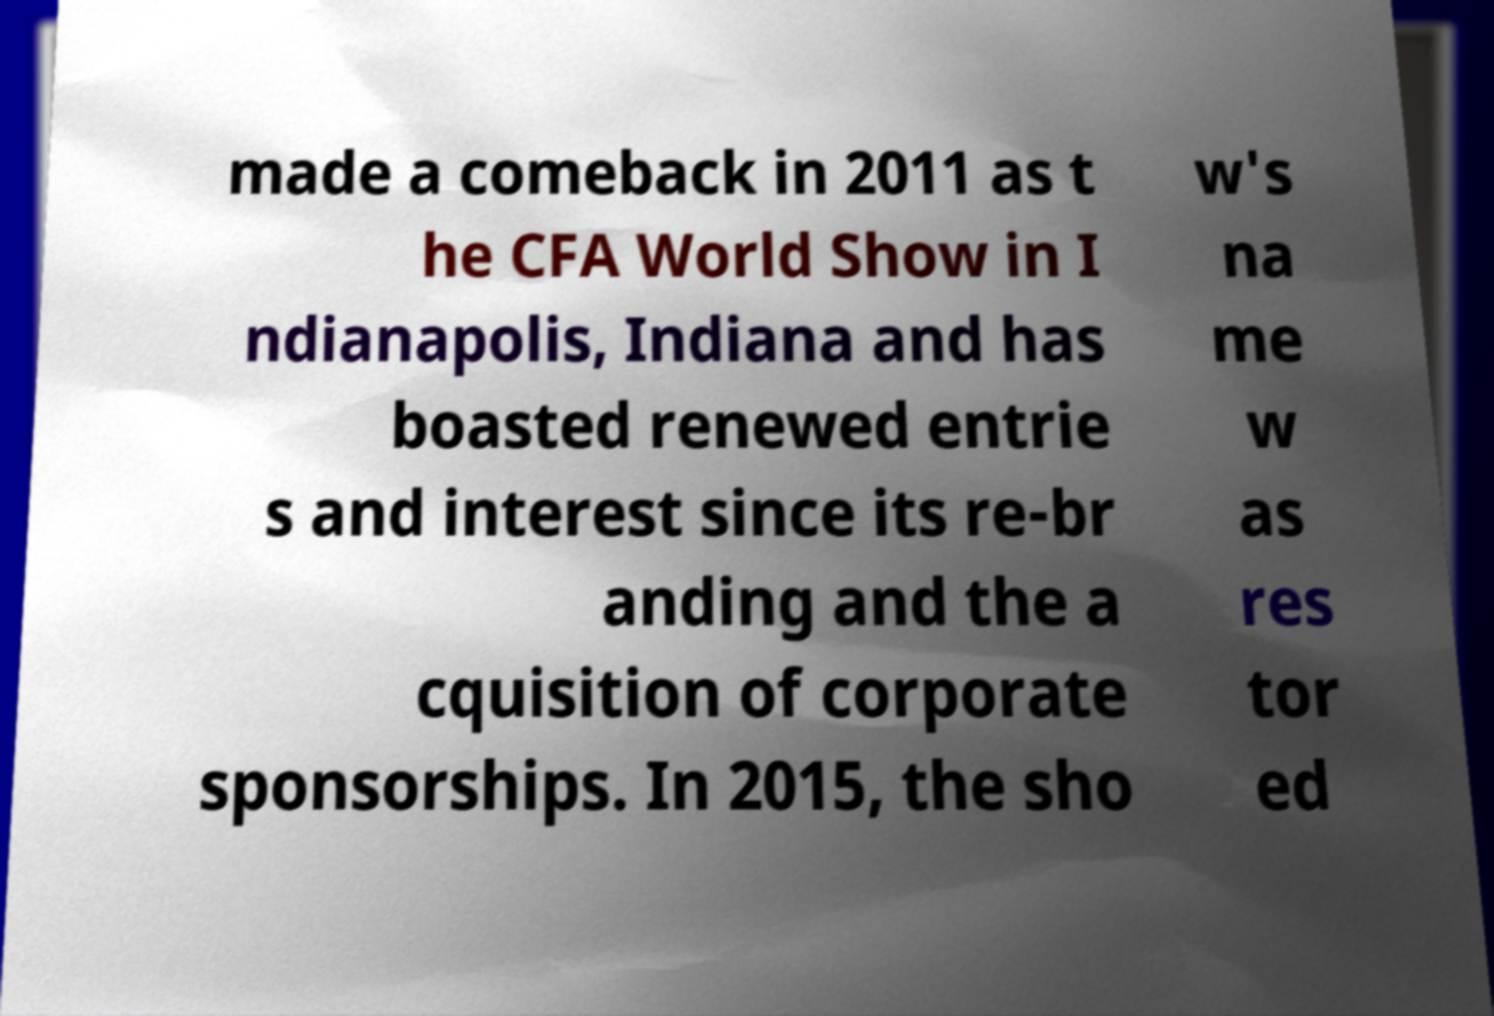Could you extract and type out the text from this image? made a comeback in 2011 as t he CFA World Show in I ndianapolis, Indiana and has boasted renewed entrie s and interest since its re-br anding and the a cquisition of corporate sponsorships. In 2015, the sho w's na me w as res tor ed 